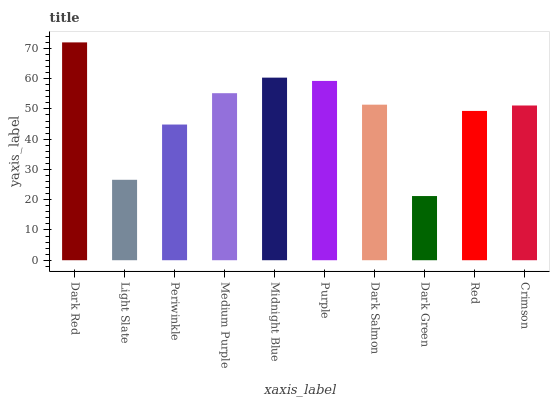Is Dark Green the minimum?
Answer yes or no. Yes. Is Dark Red the maximum?
Answer yes or no. Yes. Is Light Slate the minimum?
Answer yes or no. No. Is Light Slate the maximum?
Answer yes or no. No. Is Dark Red greater than Light Slate?
Answer yes or no. Yes. Is Light Slate less than Dark Red?
Answer yes or no. Yes. Is Light Slate greater than Dark Red?
Answer yes or no. No. Is Dark Red less than Light Slate?
Answer yes or no. No. Is Dark Salmon the high median?
Answer yes or no. Yes. Is Crimson the low median?
Answer yes or no. Yes. Is Dark Green the high median?
Answer yes or no. No. Is Dark Red the low median?
Answer yes or no. No. 